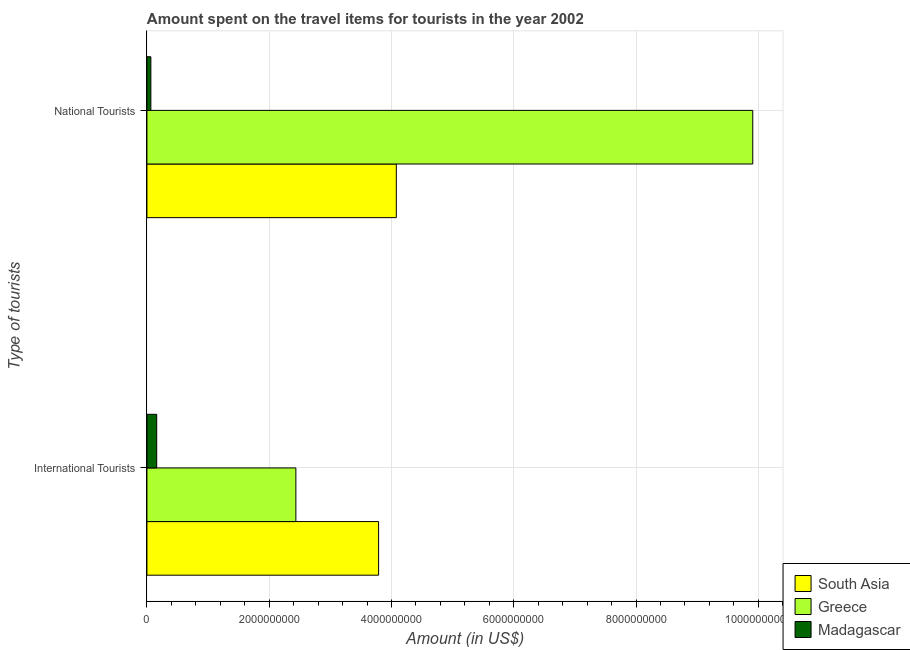Are the number of bars on each tick of the Y-axis equal?
Your answer should be very brief. Yes. How many bars are there on the 2nd tick from the bottom?
Provide a short and direct response. 3. What is the label of the 2nd group of bars from the top?
Give a very brief answer. International Tourists. What is the amount spent on travel items of national tourists in South Asia?
Your answer should be very brief. 4.08e+09. Across all countries, what is the maximum amount spent on travel items of national tourists?
Offer a terse response. 9.91e+09. Across all countries, what is the minimum amount spent on travel items of national tourists?
Make the answer very short. 6.40e+07. In which country was the amount spent on travel items of international tourists minimum?
Offer a very short reply. Madagascar. What is the total amount spent on travel items of national tourists in the graph?
Provide a short and direct response. 1.41e+1. What is the difference between the amount spent on travel items of international tourists in South Asia and that in Madagascar?
Your answer should be very brief. 3.63e+09. What is the difference between the amount spent on travel items of national tourists in Greece and the amount spent on travel items of international tourists in Madagascar?
Give a very brief answer. 9.75e+09. What is the average amount spent on travel items of international tourists per country?
Keep it short and to the point. 2.13e+09. What is the difference between the amount spent on travel items of international tourists and amount spent on travel items of national tourists in Madagascar?
Offer a very short reply. 9.60e+07. In how many countries, is the amount spent on travel items of international tourists greater than 4000000000 US$?
Make the answer very short. 0. What is the ratio of the amount spent on travel items of national tourists in Greece to that in South Asia?
Provide a short and direct response. 2.43. Is the amount spent on travel items of international tourists in South Asia less than that in Greece?
Provide a succinct answer. No. In how many countries, is the amount spent on travel items of national tourists greater than the average amount spent on travel items of national tourists taken over all countries?
Offer a terse response. 1. What does the 1st bar from the bottom in International Tourists represents?
Provide a succinct answer. South Asia. What is the difference between two consecutive major ticks on the X-axis?
Ensure brevity in your answer.  2.00e+09. Are the values on the major ticks of X-axis written in scientific E-notation?
Your answer should be compact. No. Does the graph contain any zero values?
Provide a succinct answer. No. Where does the legend appear in the graph?
Give a very brief answer. Bottom right. What is the title of the graph?
Provide a succinct answer. Amount spent on the travel items for tourists in the year 2002. Does "Ukraine" appear as one of the legend labels in the graph?
Provide a succinct answer. No. What is the label or title of the Y-axis?
Your response must be concise. Type of tourists. What is the Amount (in US$) of South Asia in International Tourists?
Make the answer very short. 3.79e+09. What is the Amount (in US$) in Greece in International Tourists?
Provide a short and direct response. 2.44e+09. What is the Amount (in US$) in Madagascar in International Tourists?
Provide a short and direct response. 1.60e+08. What is the Amount (in US$) of South Asia in National Tourists?
Provide a succinct answer. 4.08e+09. What is the Amount (in US$) in Greece in National Tourists?
Your answer should be compact. 9.91e+09. What is the Amount (in US$) in Madagascar in National Tourists?
Offer a terse response. 6.40e+07. Across all Type of tourists, what is the maximum Amount (in US$) in South Asia?
Provide a succinct answer. 4.08e+09. Across all Type of tourists, what is the maximum Amount (in US$) of Greece?
Your answer should be compact. 9.91e+09. Across all Type of tourists, what is the maximum Amount (in US$) of Madagascar?
Your response must be concise. 1.60e+08. Across all Type of tourists, what is the minimum Amount (in US$) of South Asia?
Provide a short and direct response. 3.79e+09. Across all Type of tourists, what is the minimum Amount (in US$) of Greece?
Your answer should be very brief. 2.44e+09. Across all Type of tourists, what is the minimum Amount (in US$) of Madagascar?
Your response must be concise. 6.40e+07. What is the total Amount (in US$) of South Asia in the graph?
Ensure brevity in your answer.  7.87e+09. What is the total Amount (in US$) of Greece in the graph?
Ensure brevity in your answer.  1.23e+1. What is the total Amount (in US$) of Madagascar in the graph?
Provide a succinct answer. 2.24e+08. What is the difference between the Amount (in US$) in South Asia in International Tourists and that in National Tourists?
Ensure brevity in your answer.  -2.90e+08. What is the difference between the Amount (in US$) of Greece in International Tourists and that in National Tourists?
Offer a terse response. -7.47e+09. What is the difference between the Amount (in US$) in Madagascar in International Tourists and that in National Tourists?
Your answer should be very brief. 9.60e+07. What is the difference between the Amount (in US$) of South Asia in International Tourists and the Amount (in US$) of Greece in National Tourists?
Your response must be concise. -6.12e+09. What is the difference between the Amount (in US$) in South Asia in International Tourists and the Amount (in US$) in Madagascar in National Tourists?
Offer a very short reply. 3.72e+09. What is the difference between the Amount (in US$) of Greece in International Tourists and the Amount (in US$) of Madagascar in National Tourists?
Offer a terse response. 2.37e+09. What is the average Amount (in US$) of South Asia per Type of tourists?
Your response must be concise. 3.93e+09. What is the average Amount (in US$) of Greece per Type of tourists?
Offer a very short reply. 6.17e+09. What is the average Amount (in US$) of Madagascar per Type of tourists?
Your response must be concise. 1.12e+08. What is the difference between the Amount (in US$) in South Asia and Amount (in US$) in Greece in International Tourists?
Your response must be concise. 1.35e+09. What is the difference between the Amount (in US$) of South Asia and Amount (in US$) of Madagascar in International Tourists?
Your answer should be compact. 3.63e+09. What is the difference between the Amount (in US$) of Greece and Amount (in US$) of Madagascar in International Tourists?
Ensure brevity in your answer.  2.28e+09. What is the difference between the Amount (in US$) of South Asia and Amount (in US$) of Greece in National Tourists?
Your answer should be compact. -5.83e+09. What is the difference between the Amount (in US$) of South Asia and Amount (in US$) of Madagascar in National Tourists?
Provide a short and direct response. 4.01e+09. What is the difference between the Amount (in US$) in Greece and Amount (in US$) in Madagascar in National Tourists?
Your answer should be compact. 9.84e+09. What is the ratio of the Amount (in US$) of South Asia in International Tourists to that in National Tourists?
Keep it short and to the point. 0.93. What is the ratio of the Amount (in US$) of Greece in International Tourists to that in National Tourists?
Give a very brief answer. 0.25. What is the ratio of the Amount (in US$) of Madagascar in International Tourists to that in National Tourists?
Provide a short and direct response. 2.5. What is the difference between the highest and the second highest Amount (in US$) in South Asia?
Make the answer very short. 2.90e+08. What is the difference between the highest and the second highest Amount (in US$) in Greece?
Keep it short and to the point. 7.47e+09. What is the difference between the highest and the second highest Amount (in US$) in Madagascar?
Offer a very short reply. 9.60e+07. What is the difference between the highest and the lowest Amount (in US$) in South Asia?
Ensure brevity in your answer.  2.90e+08. What is the difference between the highest and the lowest Amount (in US$) of Greece?
Keep it short and to the point. 7.47e+09. What is the difference between the highest and the lowest Amount (in US$) in Madagascar?
Offer a very short reply. 9.60e+07. 